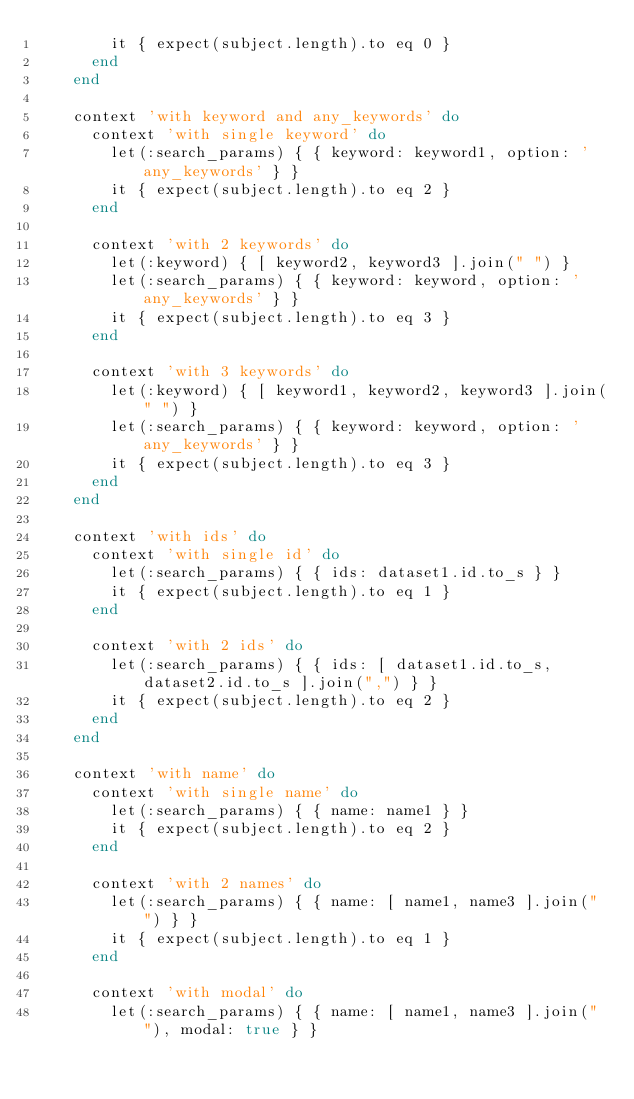<code> <loc_0><loc_0><loc_500><loc_500><_Ruby_>        it { expect(subject.length).to eq 0 }
      end
    end

    context 'with keyword and any_keywords' do
      context 'with single keyword' do
        let(:search_params) { { keyword: keyword1, option: 'any_keywords' } }
        it { expect(subject.length).to eq 2 }
      end

      context 'with 2 keywords' do
        let(:keyword) { [ keyword2, keyword3 ].join(" ") }
        let(:search_params) { { keyword: keyword, option: 'any_keywords' } }
        it { expect(subject.length).to eq 3 }
      end

      context 'with 3 keywords' do
        let(:keyword) { [ keyword1, keyword2, keyword3 ].join(" ") }
        let(:search_params) { { keyword: keyword, option: 'any_keywords' } }
        it { expect(subject.length).to eq 3 }
      end
    end

    context 'with ids' do
      context 'with single id' do
        let(:search_params) { { ids: dataset1.id.to_s } }
        it { expect(subject.length).to eq 1 }
      end

      context 'with 2 ids' do
        let(:search_params) { { ids: [ dataset1.id.to_s, dataset2.id.to_s ].join(",") } }
        it { expect(subject.length).to eq 2 }
      end
    end

    context 'with name' do
      context 'with single name' do
        let(:search_params) { { name: name1 } }
        it { expect(subject.length).to eq 2 }
      end

      context 'with 2 names' do
        let(:search_params) { { name: [ name1, name3 ].join(" ") } }
        it { expect(subject.length).to eq 1 }
      end

      context 'with modal' do
        let(:search_params) { { name: [ name1, name3 ].join(" "), modal: true } }</code> 